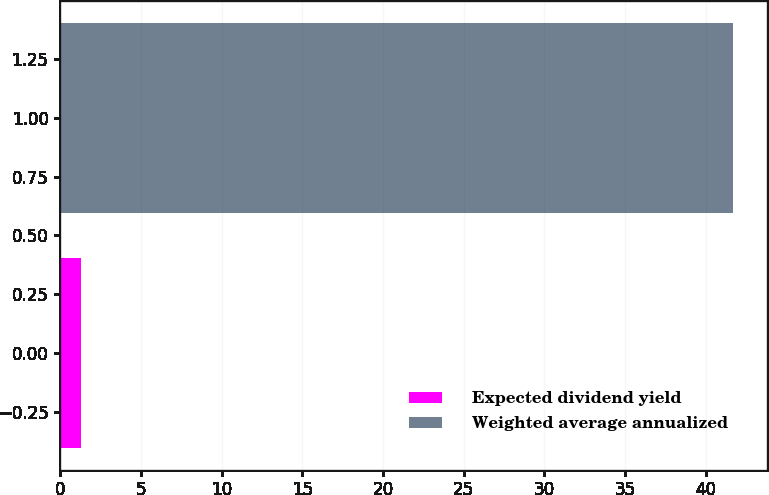Convert chart to OTSL. <chart><loc_0><loc_0><loc_500><loc_500><bar_chart><fcel>Expected dividend yield<fcel>Weighted average annualized<nl><fcel>1.3<fcel>41.7<nl></chart> 